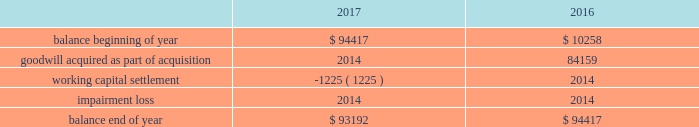Note 4 - goodwill and other intangible assets : goodwill the company had approximately $ 93.2 million and $ 94.4 million of goodwill at december 30 , 2017 and december 31 , 2016 , respectively .
The changes in the carrying amount of goodwill for the years ended december 30 , 2017 and december 31 , 2016 are as follows ( in thousands ) : .
Goodwill is allocated to each identified reporting unit , which is defined as an operating segment or one level below the operating segment .
Goodwill is not amortized , but is evaluated for impairment annually and whenever events or changes in circumstances indicate the carrying value of goodwill may not be recoverable .
The company completes its impairment evaluation by performing valuation analyses and considering other publicly available market information , as appropriate .
The test used to identify the potential for goodwill impairment compares the fair value of a reporting unit with its carrying value .
An impairment charge would be recorded to the company 2019s operations for the amount , if any , in which the carrying value exceeds the fair value .
In the fourth quarter of fiscal 2017 , the company completed its annual impairment testing of goodwill and no impairment was identified .
The company determined that the fair value of each reporting unit ( including goodwill ) was in excess of the carrying value of the respective reporting unit .
In reaching this conclusion , the fair value of each reporting unit was determined based on either a market or an income approach .
Under the market approach , the fair value is based on observed market data .
Other intangible assets the company had approximately $ 31.3 million of intangible assets other than goodwill at december 30 , 2017 and december 31 , 2016 .
The intangible asset balance represents the estimated fair value of the petsense tradename , which is not subject to amortization as it has an indefinite useful life on the basis that it is expected to contribute cash flows beyond the foreseeable horizon .
With respect to intangible assets , we evaluate for impairment annually and whenever events or changes in circumstances indicate that the carrying value may not be recoverable .
We recognize an impairment loss only if the carrying amount is not recoverable through its discounted cash flows and measure the impairment loss based on the difference between the carrying value and fair value .
In the fourth quarter of fiscal 2017 , the company completed its annual impairment testing of intangible assets and no impairment was identified. .
What was the ratio of the goodwill and other intangible assets for the company had approximately in 2017 to 2016? 
Computations: (93.2 / 94.4)
Answer: 0.98729. 